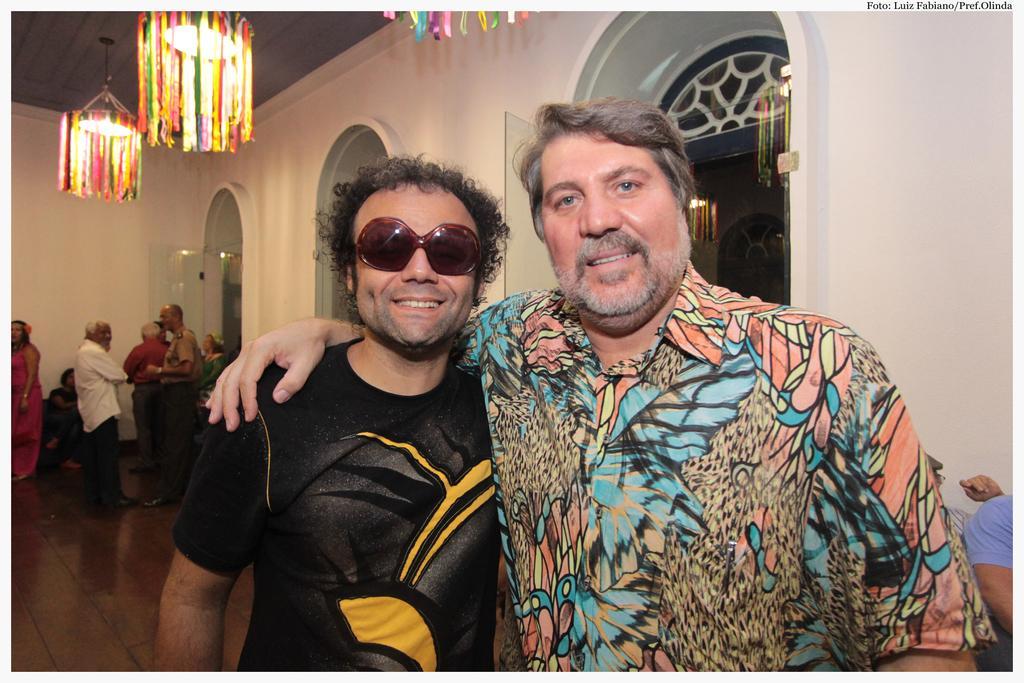How would you summarize this image in a sentence or two? In this picture we can see some people standing, two men in the front are smiling, in the background there is a wall, we can see two lamps and ribbons here, there is some text at the right top of the picture. 